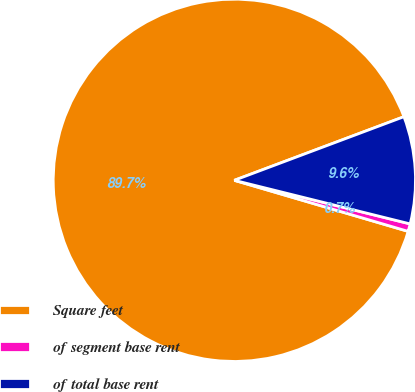Convert chart to OTSL. <chart><loc_0><loc_0><loc_500><loc_500><pie_chart><fcel>Square feet<fcel>of segment base rent<fcel>of total base rent<nl><fcel>89.74%<fcel>0.68%<fcel>9.58%<nl></chart> 